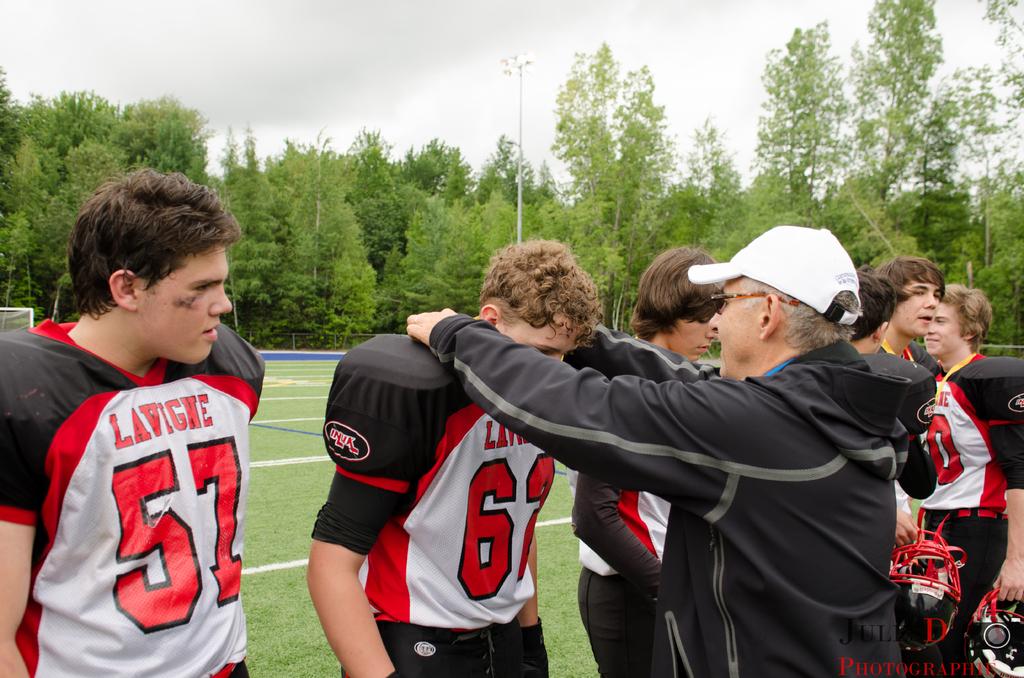What jersey number is the player on the left?
Your answer should be compact. 57. 